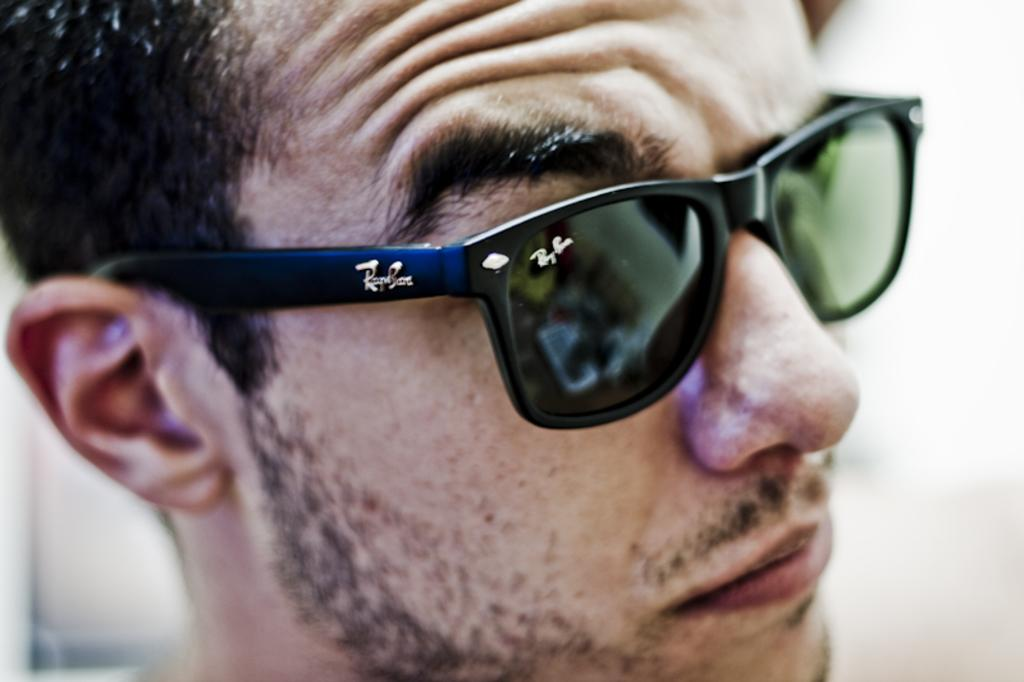What is the main subject of the image? The main subject of the image is a man's head. What is the man wearing in the image? The man is wearing black color goggles in the image. In which direction is the man looking? The man is looking at the right side in the image. What type of cave can be seen in the background of the image? There is no cave present in the image. Can you tell me how many feathers are on the man's head in the image? There are no feathers present on the man's head in the image. 